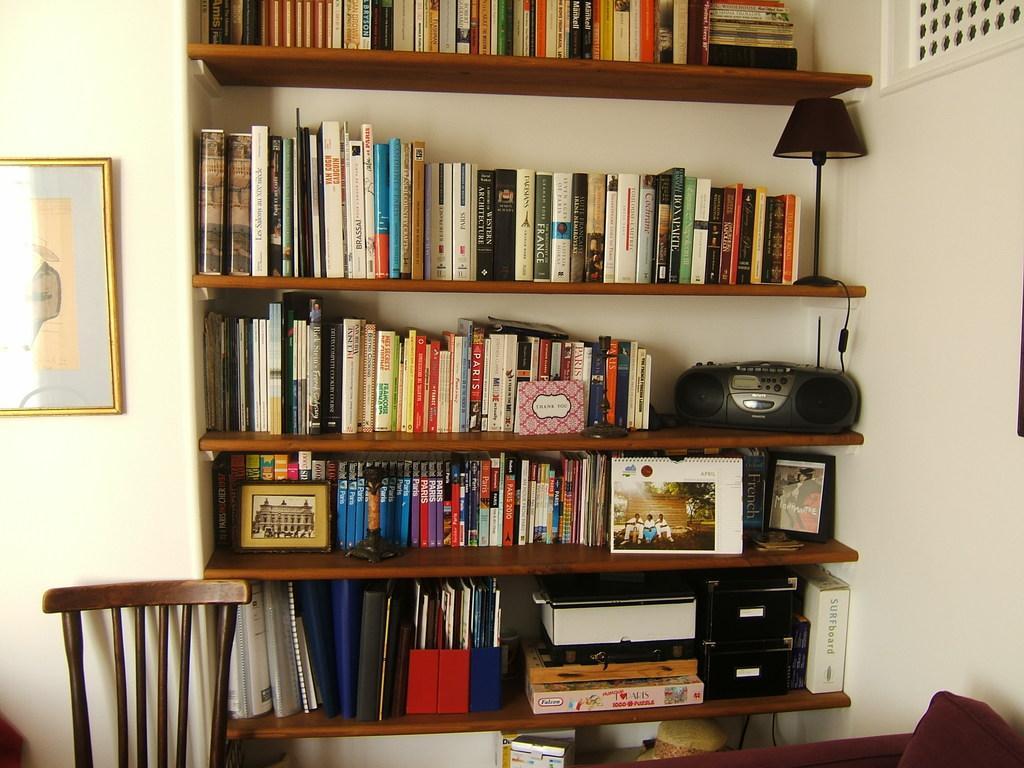Can you describe this image briefly? In this image I can see number of books on these shelves. I can also see a black colour radio, a lamp, a frame and few other things on these shelves. Here I can see a chair and on this wall I can see a frame. 